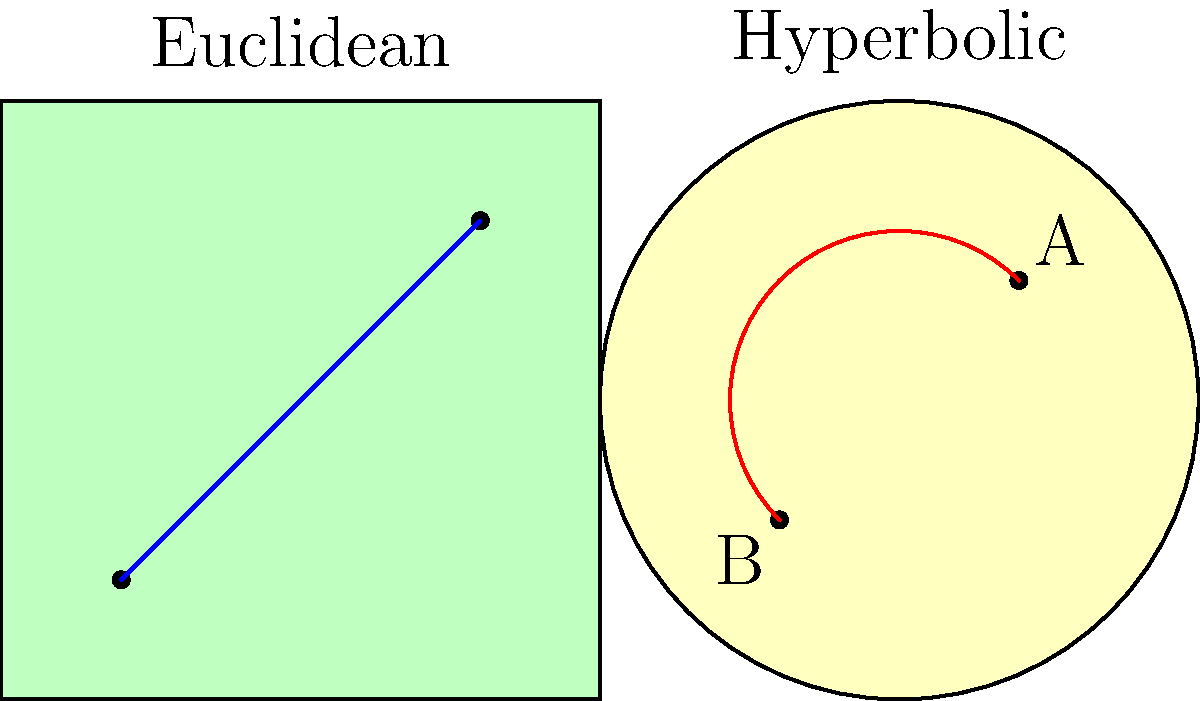In your role of preserving game cabinets, you've encountered a unique puzzle game that compares paths in different geometries. The game shows two planes: a flat Euclidean plane and a hyperbolic plane represented by a Poincaré disk model. Both planes have two points marked. On the Euclidean plane, the shortest path between the points is a straight line, while on the hyperbolic plane, it's an arc.

If the distance between the points on the Euclidean plane is $d$, and the length of the arc on the hyperbolic plane is $\frac{\pi}{2}d$, what is the ratio of the hyperbolic path length to the Euclidean path length? Let's approach this step-by-step:

1) On the Euclidean plane, the shortest path between two points is always a straight line. The length of this path is given as $d$.

2) On the hyperbolic plane, the shortest path between two points is an arc of a circle that intersects the boundary of the Poincaré disk at right angles. We're told that the length of this arc is $\frac{\pi}{2}d$.

3) To find the ratio of the hyperbolic path length to the Euclidean path length, we divide the hyperbolic length by the Euclidean length:

   $\text{Ratio} = \frac{\text{Hyperbolic length}}{\text{Euclidean length}} = \frac{\frac{\pi}{2}d}{d}$

4) The $d$ cancels out in this division:

   $\text{Ratio} = \frac{\frac{\pi}{2}d}{d} = \frac{\pi}{2}$

5) Therefore, the ratio of the hyperbolic path length to the Euclidean path length is $\frac{\pi}{2}$.
Answer: $\frac{\pi}{2}$ 